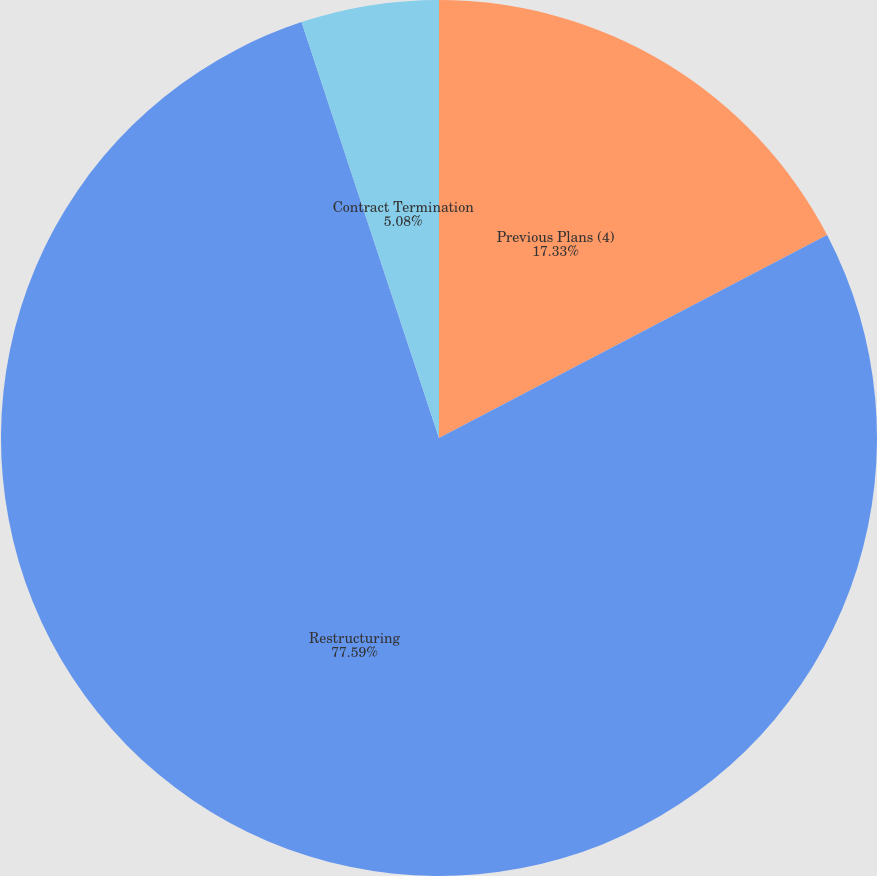Convert chart to OTSL. <chart><loc_0><loc_0><loc_500><loc_500><pie_chart><fcel>Previous Plans (4)<fcel>Restructuring<fcel>Contract Termination<nl><fcel>17.33%<fcel>77.59%<fcel>5.08%<nl></chart> 